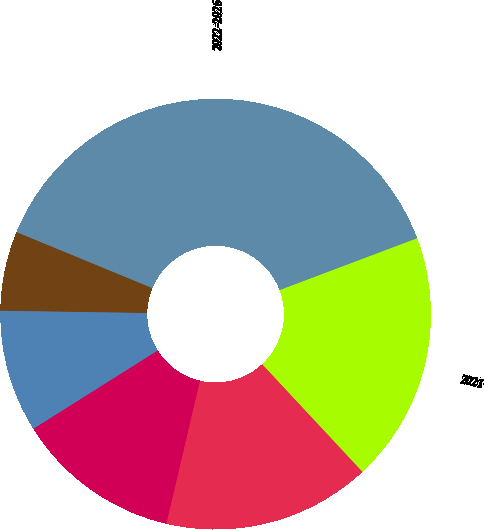<chart> <loc_0><loc_0><loc_500><loc_500><pie_chart><fcel>2017<fcel>2018<fcel>2019<fcel>2020<fcel>2021<fcel>2022-2026<nl><fcel>5.98%<fcel>9.19%<fcel>12.39%<fcel>15.6%<fcel>18.8%<fcel>38.03%<nl></chart> 